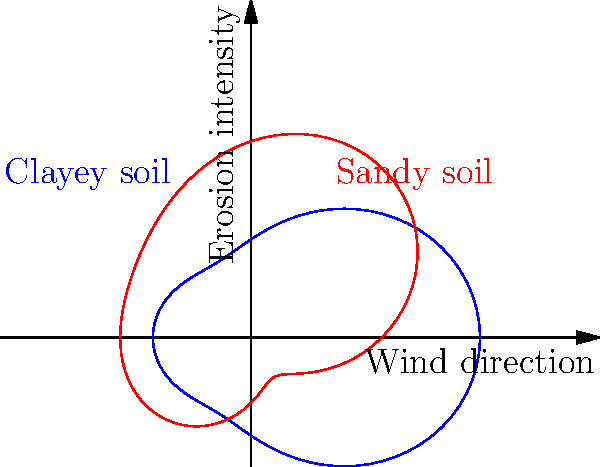As a landscape architect, you're assessing wind erosion patterns for different soil types in your construction project. The polar graph shows erosion intensity for clayey (blue) and sandy (red) soils across various wind directions. Which soil type exhibits greater variability in erosion intensity, and what might this imply for your erosion control strategies? To determine which soil type shows greater variability in erosion intensity, we need to analyze the polar graphs:

1. Observe the overall shape of both curves:
   - The blue curve (clayey soil) is more circular and uniform.
   - The red curve (sandy soil) has more pronounced lobes and indentations.

2. Interpret the distance from the center:
   - Greater distance indicates higher erosion intensity.
   - The red curve shows more significant changes in distance from the center across different angles.

3. Compare the range of distances:
   - The blue curve has a smaller range of distances from the center.
   - The red curve has a larger range, with more extreme maximums and minimums.

4. Conclude on variability:
   - Sandy soil (red) exhibits greater variability in erosion intensity across different wind directions.

5. Implications for erosion control strategies:
   - Sandy soil will require more adaptable and robust erosion control measures.
   - Different wind directions will have varying impacts on sandy soil erosion.
   - Clayey soil may allow for more uniform erosion control strategies.

Therefore, sandy soil shows greater variability in erosion intensity, implying the need for more diverse and direction-specific erosion control strategies in areas with sandy soil.
Answer: Sandy soil; requires direction-specific erosion control. 